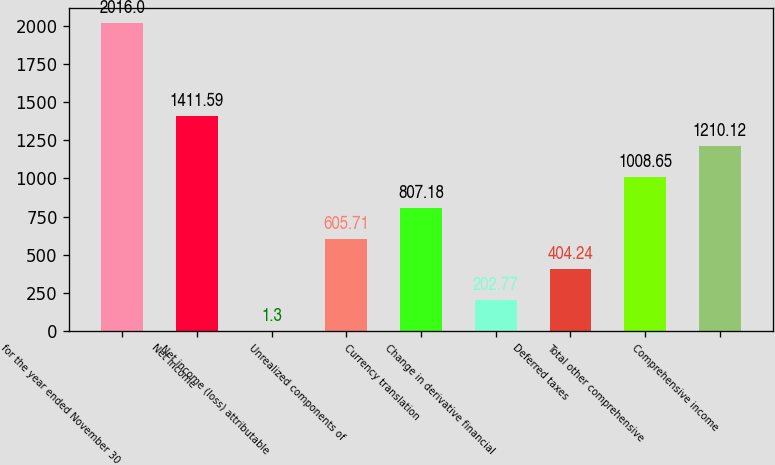Convert chart. <chart><loc_0><loc_0><loc_500><loc_500><bar_chart><fcel>for the year ended November 30<fcel>Net income<fcel>Net income (loss) attributable<fcel>Unrealized components of<fcel>Currency translation<fcel>Change in derivative financial<fcel>Deferred taxes<fcel>Total other comprehensive<fcel>Comprehensive income<nl><fcel>2016<fcel>1411.59<fcel>1.3<fcel>605.71<fcel>807.18<fcel>202.77<fcel>404.24<fcel>1008.65<fcel>1210.12<nl></chart> 